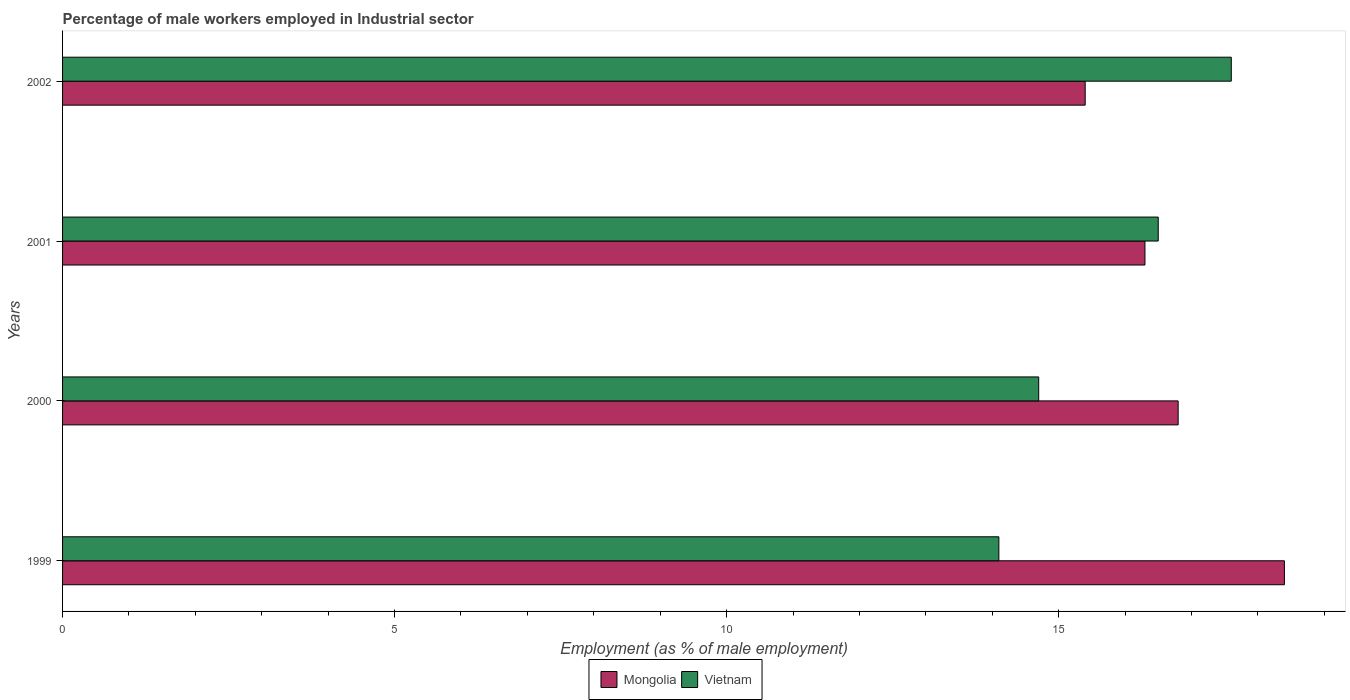Are the number of bars on each tick of the Y-axis equal?
Keep it short and to the point. Yes. How many bars are there on the 1st tick from the top?
Offer a terse response. 2. How many bars are there on the 1st tick from the bottom?
Provide a succinct answer. 2. What is the label of the 1st group of bars from the top?
Your response must be concise. 2002. What is the percentage of male workers employed in Industrial sector in Mongolia in 2000?
Your answer should be compact. 16.8. Across all years, what is the maximum percentage of male workers employed in Industrial sector in Mongolia?
Provide a short and direct response. 18.4. Across all years, what is the minimum percentage of male workers employed in Industrial sector in Vietnam?
Ensure brevity in your answer.  14.1. In which year was the percentage of male workers employed in Industrial sector in Mongolia maximum?
Your response must be concise. 1999. What is the total percentage of male workers employed in Industrial sector in Vietnam in the graph?
Your response must be concise. 62.9. What is the difference between the percentage of male workers employed in Industrial sector in Mongolia in 1999 and that in 2001?
Make the answer very short. 2.1. What is the difference between the percentage of male workers employed in Industrial sector in Vietnam in 2001 and the percentage of male workers employed in Industrial sector in Mongolia in 1999?
Provide a succinct answer. -1.9. What is the average percentage of male workers employed in Industrial sector in Vietnam per year?
Provide a short and direct response. 15.73. In the year 2002, what is the difference between the percentage of male workers employed in Industrial sector in Vietnam and percentage of male workers employed in Industrial sector in Mongolia?
Make the answer very short. 2.2. In how many years, is the percentage of male workers employed in Industrial sector in Mongolia greater than 12 %?
Your answer should be compact. 4. What is the ratio of the percentage of male workers employed in Industrial sector in Vietnam in 2001 to that in 2002?
Ensure brevity in your answer.  0.94. Is the percentage of male workers employed in Industrial sector in Vietnam in 1999 less than that in 2002?
Provide a succinct answer. Yes. Is the difference between the percentage of male workers employed in Industrial sector in Vietnam in 2001 and 2002 greater than the difference between the percentage of male workers employed in Industrial sector in Mongolia in 2001 and 2002?
Make the answer very short. No. What is the difference between the highest and the second highest percentage of male workers employed in Industrial sector in Vietnam?
Keep it short and to the point. 1.1. What is the difference between the highest and the lowest percentage of male workers employed in Industrial sector in Vietnam?
Make the answer very short. 3.5. Is the sum of the percentage of male workers employed in Industrial sector in Mongolia in 1999 and 2002 greater than the maximum percentage of male workers employed in Industrial sector in Vietnam across all years?
Your response must be concise. Yes. What does the 2nd bar from the top in 2000 represents?
Provide a succinct answer. Mongolia. What does the 1st bar from the bottom in 1999 represents?
Make the answer very short. Mongolia. How many bars are there?
Offer a very short reply. 8. Are all the bars in the graph horizontal?
Provide a succinct answer. Yes. Does the graph contain any zero values?
Your answer should be compact. No. Does the graph contain grids?
Provide a succinct answer. No. What is the title of the graph?
Your response must be concise. Percentage of male workers employed in Industrial sector. What is the label or title of the X-axis?
Offer a terse response. Employment (as % of male employment). What is the label or title of the Y-axis?
Your answer should be very brief. Years. What is the Employment (as % of male employment) of Mongolia in 1999?
Your response must be concise. 18.4. What is the Employment (as % of male employment) of Vietnam in 1999?
Make the answer very short. 14.1. What is the Employment (as % of male employment) in Mongolia in 2000?
Give a very brief answer. 16.8. What is the Employment (as % of male employment) of Vietnam in 2000?
Your response must be concise. 14.7. What is the Employment (as % of male employment) of Mongolia in 2001?
Ensure brevity in your answer.  16.3. What is the Employment (as % of male employment) of Mongolia in 2002?
Provide a succinct answer. 15.4. What is the Employment (as % of male employment) of Vietnam in 2002?
Provide a succinct answer. 17.6. Across all years, what is the maximum Employment (as % of male employment) of Mongolia?
Offer a very short reply. 18.4. Across all years, what is the maximum Employment (as % of male employment) of Vietnam?
Offer a terse response. 17.6. Across all years, what is the minimum Employment (as % of male employment) of Mongolia?
Provide a succinct answer. 15.4. Across all years, what is the minimum Employment (as % of male employment) in Vietnam?
Ensure brevity in your answer.  14.1. What is the total Employment (as % of male employment) in Mongolia in the graph?
Your answer should be compact. 66.9. What is the total Employment (as % of male employment) of Vietnam in the graph?
Your answer should be compact. 62.9. What is the difference between the Employment (as % of male employment) of Mongolia in 1999 and that in 2000?
Provide a short and direct response. 1.6. What is the difference between the Employment (as % of male employment) of Mongolia in 1999 and that in 2002?
Provide a succinct answer. 3. What is the difference between the Employment (as % of male employment) of Vietnam in 2000 and that in 2001?
Provide a succinct answer. -1.8. What is the difference between the Employment (as % of male employment) in Mongolia in 2000 and that in 2002?
Ensure brevity in your answer.  1.4. What is the difference between the Employment (as % of male employment) in Vietnam in 2000 and that in 2002?
Ensure brevity in your answer.  -2.9. What is the difference between the Employment (as % of male employment) in Vietnam in 2001 and that in 2002?
Your answer should be compact. -1.1. What is the difference between the Employment (as % of male employment) of Mongolia in 1999 and the Employment (as % of male employment) of Vietnam in 2000?
Ensure brevity in your answer.  3.7. What is the difference between the Employment (as % of male employment) of Mongolia in 2000 and the Employment (as % of male employment) of Vietnam in 2002?
Your answer should be compact. -0.8. What is the difference between the Employment (as % of male employment) of Mongolia in 2001 and the Employment (as % of male employment) of Vietnam in 2002?
Offer a very short reply. -1.3. What is the average Employment (as % of male employment) in Mongolia per year?
Your answer should be very brief. 16.73. What is the average Employment (as % of male employment) of Vietnam per year?
Make the answer very short. 15.72. In the year 1999, what is the difference between the Employment (as % of male employment) in Mongolia and Employment (as % of male employment) in Vietnam?
Your answer should be very brief. 4.3. In the year 2000, what is the difference between the Employment (as % of male employment) in Mongolia and Employment (as % of male employment) in Vietnam?
Your answer should be compact. 2.1. What is the ratio of the Employment (as % of male employment) in Mongolia in 1999 to that in 2000?
Ensure brevity in your answer.  1.1. What is the ratio of the Employment (as % of male employment) in Vietnam in 1999 to that in 2000?
Ensure brevity in your answer.  0.96. What is the ratio of the Employment (as % of male employment) in Mongolia in 1999 to that in 2001?
Your response must be concise. 1.13. What is the ratio of the Employment (as % of male employment) in Vietnam in 1999 to that in 2001?
Your answer should be very brief. 0.85. What is the ratio of the Employment (as % of male employment) of Mongolia in 1999 to that in 2002?
Your response must be concise. 1.19. What is the ratio of the Employment (as % of male employment) in Vietnam in 1999 to that in 2002?
Make the answer very short. 0.8. What is the ratio of the Employment (as % of male employment) of Mongolia in 2000 to that in 2001?
Offer a terse response. 1.03. What is the ratio of the Employment (as % of male employment) in Vietnam in 2000 to that in 2001?
Offer a terse response. 0.89. What is the ratio of the Employment (as % of male employment) of Vietnam in 2000 to that in 2002?
Your response must be concise. 0.84. What is the ratio of the Employment (as % of male employment) of Mongolia in 2001 to that in 2002?
Offer a very short reply. 1.06. What is the difference between the highest and the second highest Employment (as % of male employment) of Mongolia?
Make the answer very short. 1.6. What is the difference between the highest and the second highest Employment (as % of male employment) of Vietnam?
Your answer should be compact. 1.1. What is the difference between the highest and the lowest Employment (as % of male employment) in Vietnam?
Ensure brevity in your answer.  3.5. 